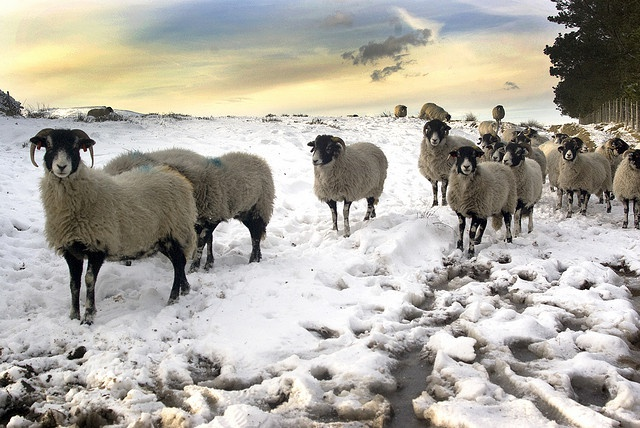Describe the objects in this image and their specific colors. I can see sheep in ivory, gray, and black tones, sheep in ivory, gray, black, and lightgray tones, sheep in ivory, gray, and darkgray tones, sheep in ivory, gray, black, and darkgray tones, and sheep in ivory, gray, and black tones in this image. 